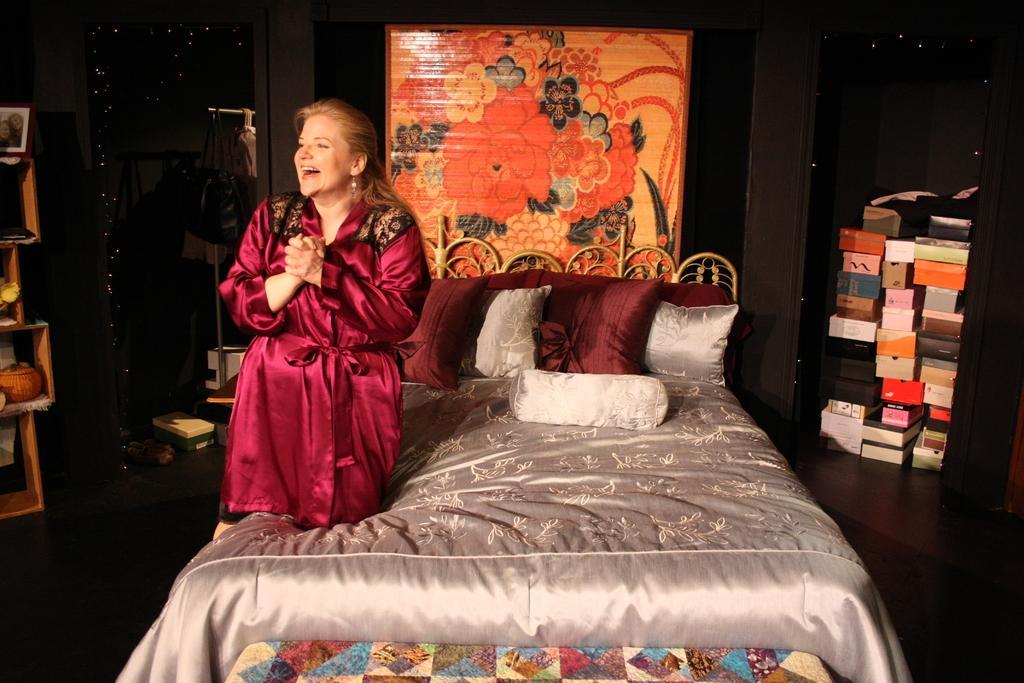Describe this image in one or two sentences. As we can see in the image there is a woman on bed. On bed there are some pillows. On the right side there are some boxes. Behind the bed there is a mat. 